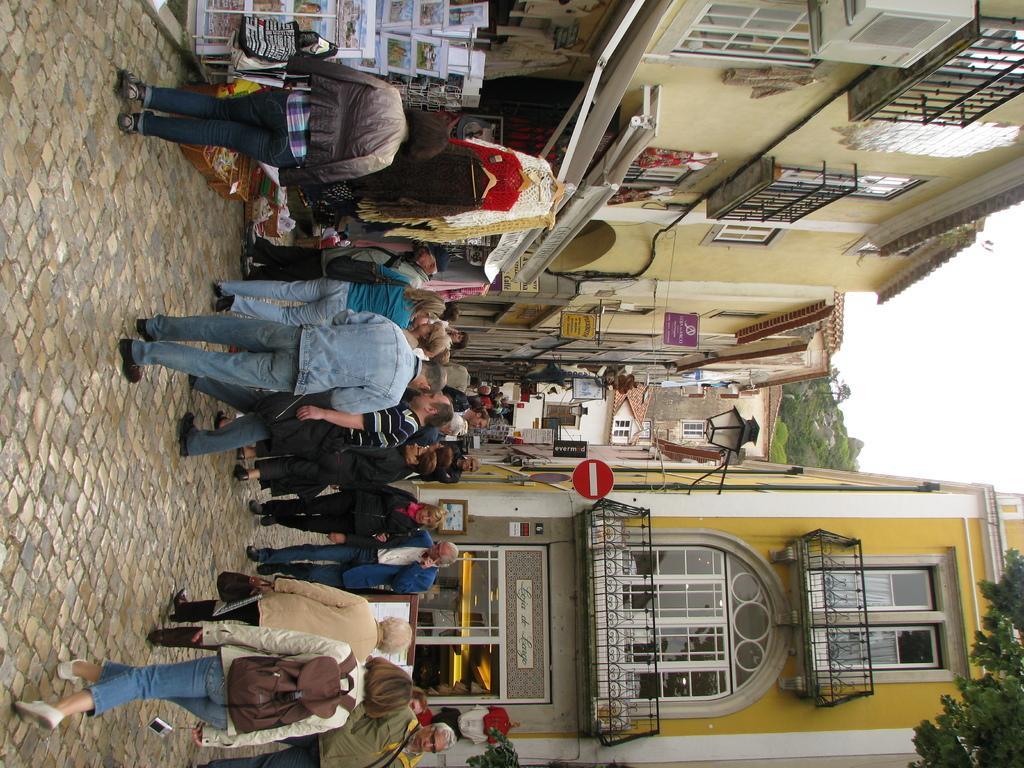Could you give a brief overview of what you see in this image? In this image people are walking on a path, on either side of the path there are buildings. 